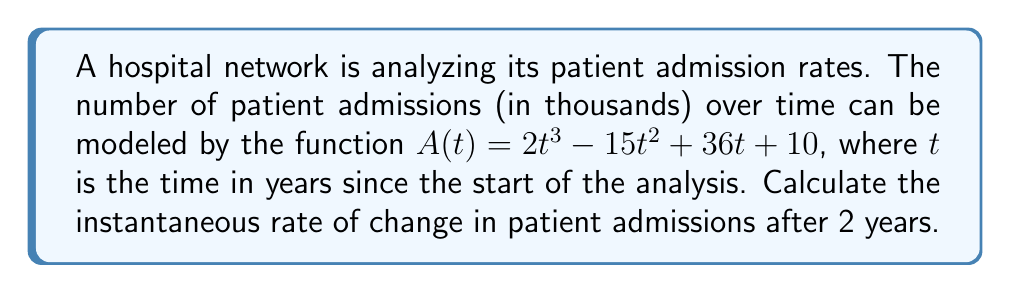Solve this math problem. To find the instantaneous rate of change in patient admissions after 2 years, we need to calculate the derivative of the function $A(t)$ and evaluate it at $t=2$. Here's the step-by-step process:

1. Given function: $A(t) = 2t^3 - 15t^2 + 36t + 10$

2. Calculate the derivative $A'(t)$ using the power rule:
   $A'(t) = 6t^2 - 30t + 36$

3. Evaluate $A'(t)$ at $t=2$:
   $A'(2) = 6(2)^2 - 30(2) + 36$
   $A'(2) = 6(4) - 60 + 36$
   $A'(2) = 24 - 60 + 36$
   $A'(2) = 0$

The instantaneous rate of change after 2 years is 0 thousand admissions per year.

This result indicates that at exactly 2 years, the rate of change in patient admissions is momentarily zero, suggesting a turning point in the admission trend.
Answer: 0 thousand admissions per year 